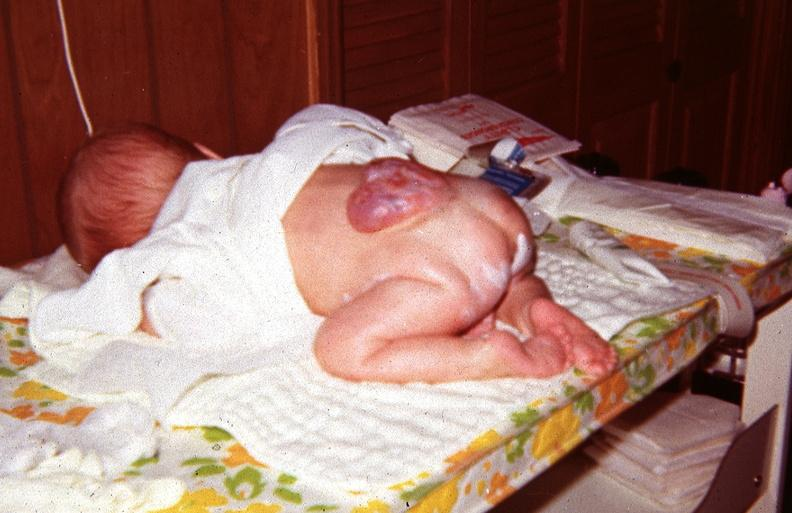does cyst show neural tube defect?
Answer the question using a single word or phrase. No 